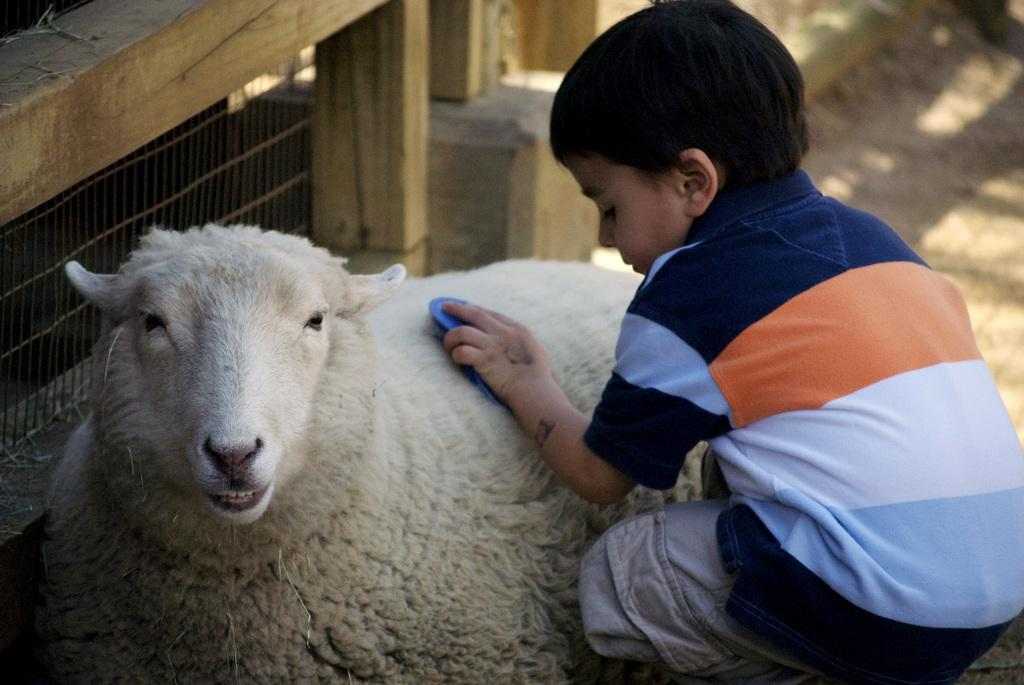What is located in the foreground of the picture? There is a boy and a sheep in the foreground of the picture. What can be seen at the top of the picture? There is a wooden frame at the top of the picture. How would you describe the right side of the picture? The right side of the picture is blurred. What is the weather like in the image? The weather is sunny. What type of rice is being served to the coach in the image? There is no coach or rice present in the image. 